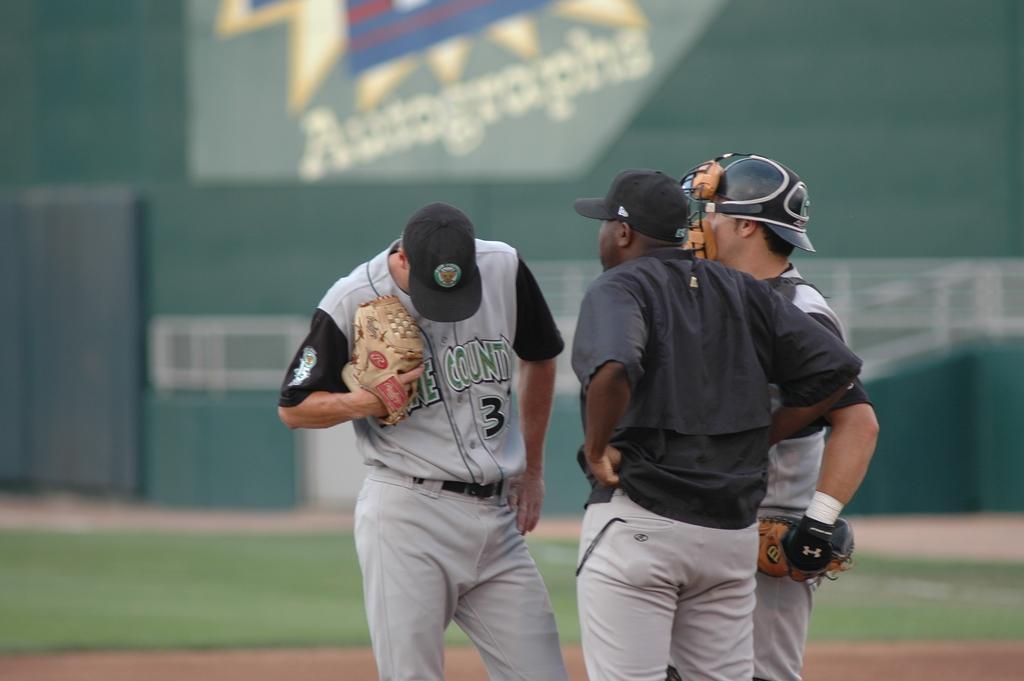Describe this image in one or two sentences. In this image in front there are three persons standing on the ground. Behind them there's grass on the surface. On the backside there is a wall with the painting on it. 